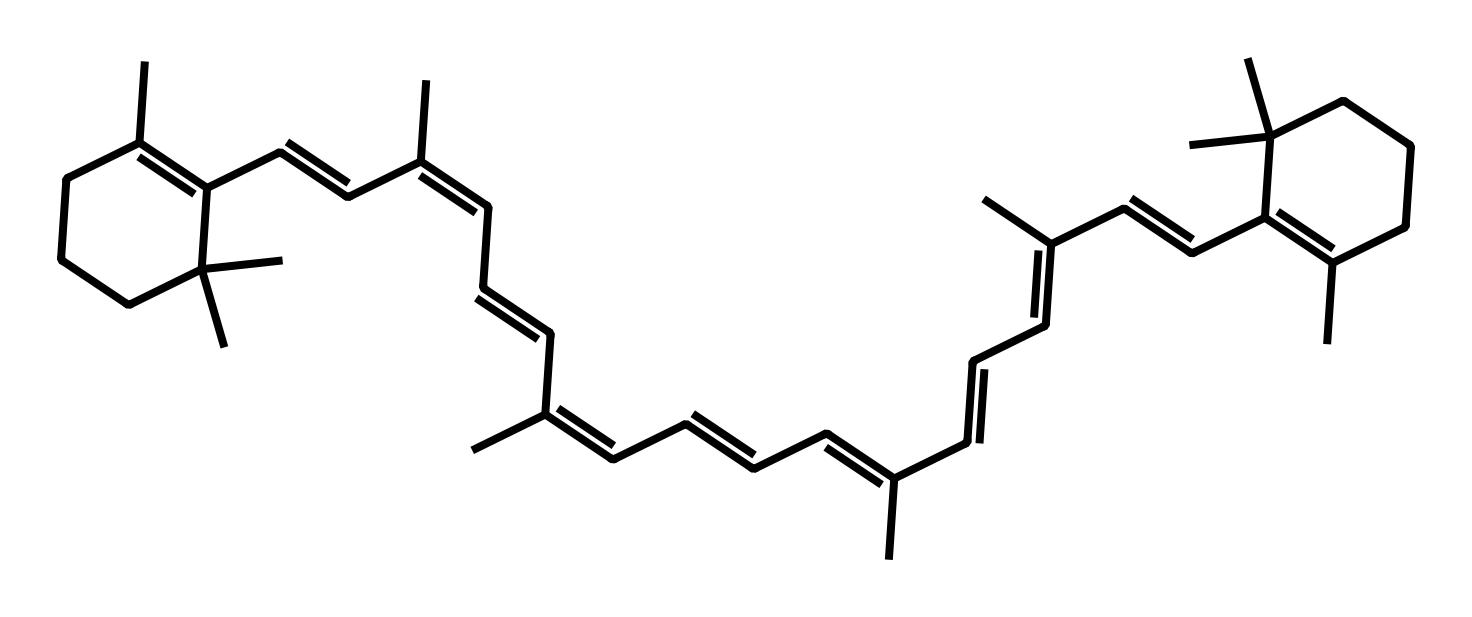What is the chemical name of this compound? The SMILES representation corresponds to the structure of beta-carotene, which is commonly recognized as a precursor to vitamin A.
Answer: beta-carotene How many carbon atoms are in the structure? By analyzing the SMILES string, we can identify that there are 40 carbon atoms present in the structure. Each 'C' represents a carbon atom.
Answer: 40 What type of compound is beta-carotene classified as? Beta-carotene is classified as a carotenoid, which is a type of antioxidant pigment found in many fruits and vegetables.
Answer: carotenoid What is the number of double bonds in the molecule? The structure reveals that beta-carotene has a total of 11 double bonds as indicated by the alternating single and double carbon connections.
Answer: 11 Which functional group is predominant in this molecule? The molecule primarily consists of carbon and hydrogen and lacks functional groups such as hydroxyl or carbonyl, indicating it is primarily hydrocarbon in nature.
Answer: hydrocarbon How does beta-carotene benefit human health? Beta-carotene acts as an antioxidant in the body, protecting cells from oxidative damage and contributing to vision health.
Answer: antioxidant 